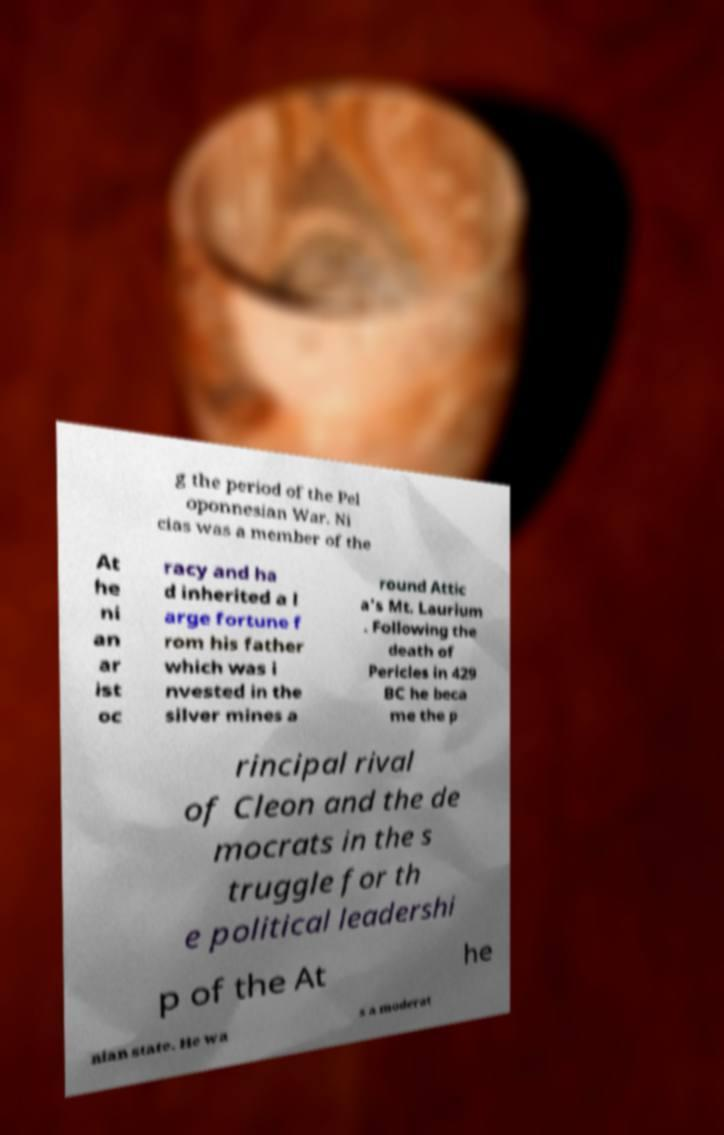What messages or text are displayed in this image? I need them in a readable, typed format. g the period of the Pel oponnesian War. Ni cias was a member of the At he ni an ar ist oc racy and ha d inherited a l arge fortune f rom his father which was i nvested in the silver mines a round Attic a's Mt. Laurium . Following the death of Pericles in 429 BC he beca me the p rincipal rival of Cleon and the de mocrats in the s truggle for th e political leadershi p of the At he nian state. He wa s a moderat 